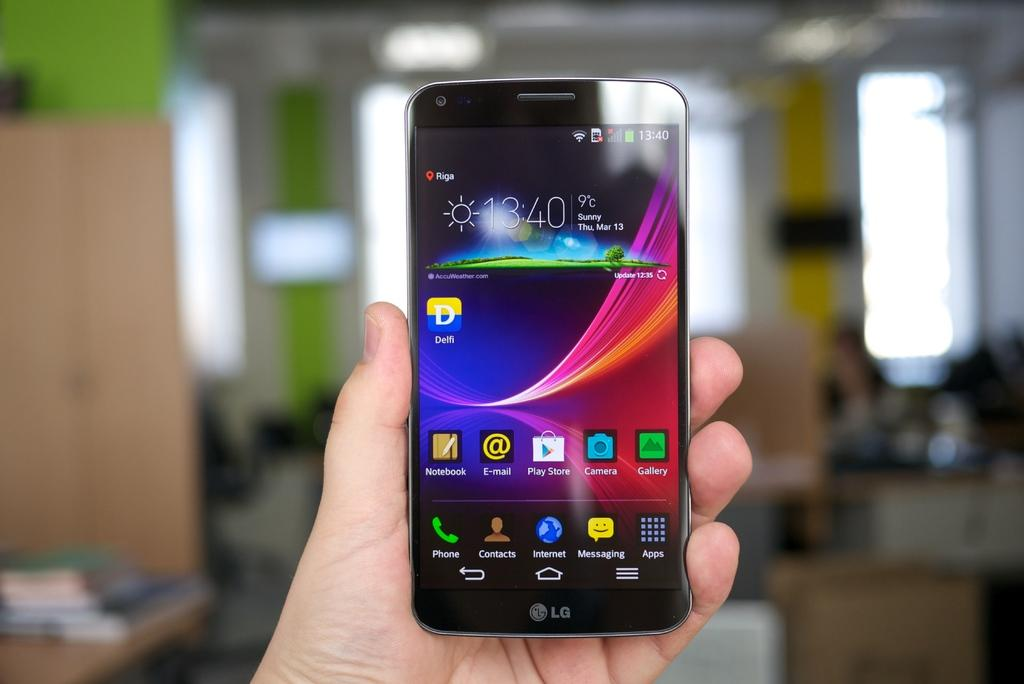<image>
Present a compact description of the photo's key features. A person is holding an LG smart phone that shows the weather, the time and a couple of icons. 